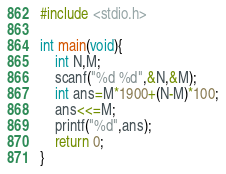<code> <loc_0><loc_0><loc_500><loc_500><_C_>#include <stdio.h>

int main(void){
    int N,M;
    scanf("%d %d",&N,&M);
    int ans=M*1900+(N-M)*100;
    ans<<=M;
    printf("%d",ans);
    return 0;
}
</code> 